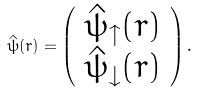<formula> <loc_0><loc_0><loc_500><loc_500>\hat { \psi } ( r ) = \left ( \begin{array} { c } \hat { \psi } _ { \uparrow } ( r ) \\ \hat { \psi } _ { \downarrow } ( r ) \end{array} \right ) .</formula> 